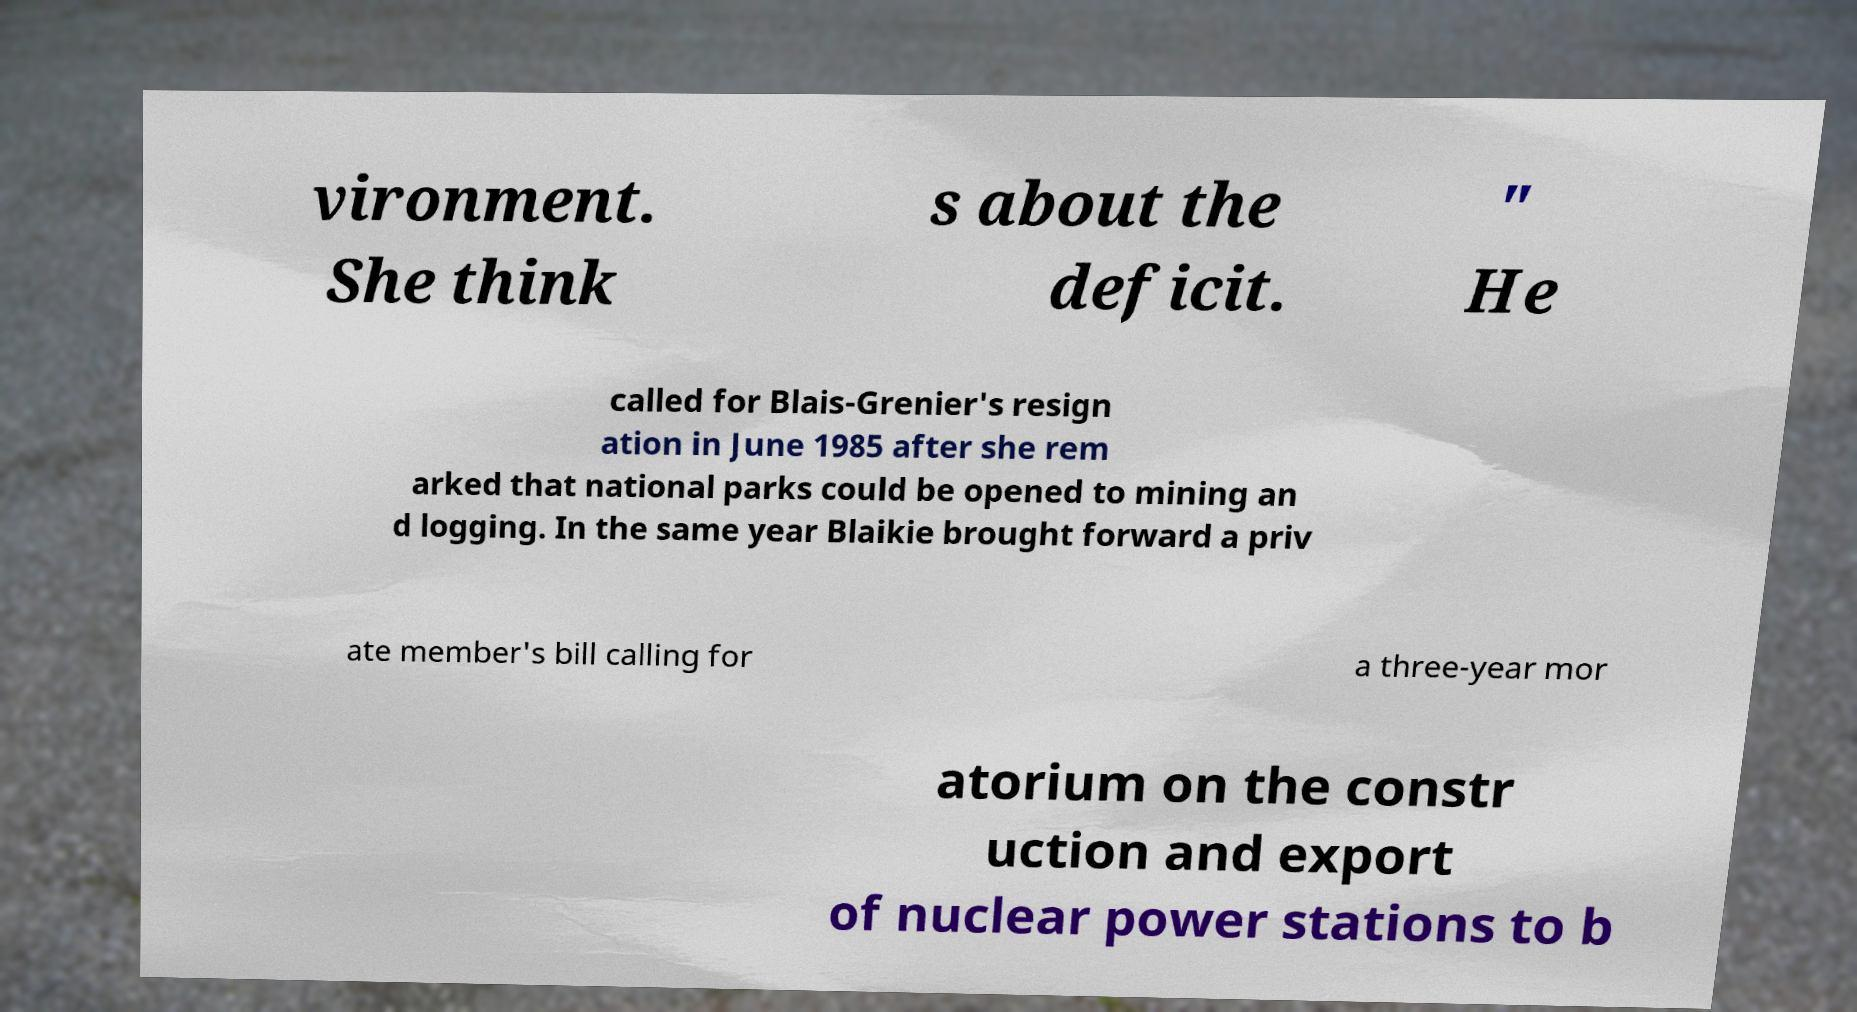What messages or text are displayed in this image? I need them in a readable, typed format. vironment. She think s about the deficit. " He called for Blais-Grenier's resign ation in June 1985 after she rem arked that national parks could be opened to mining an d logging. In the same year Blaikie brought forward a priv ate member's bill calling for a three-year mor atorium on the constr uction and export of nuclear power stations to b 